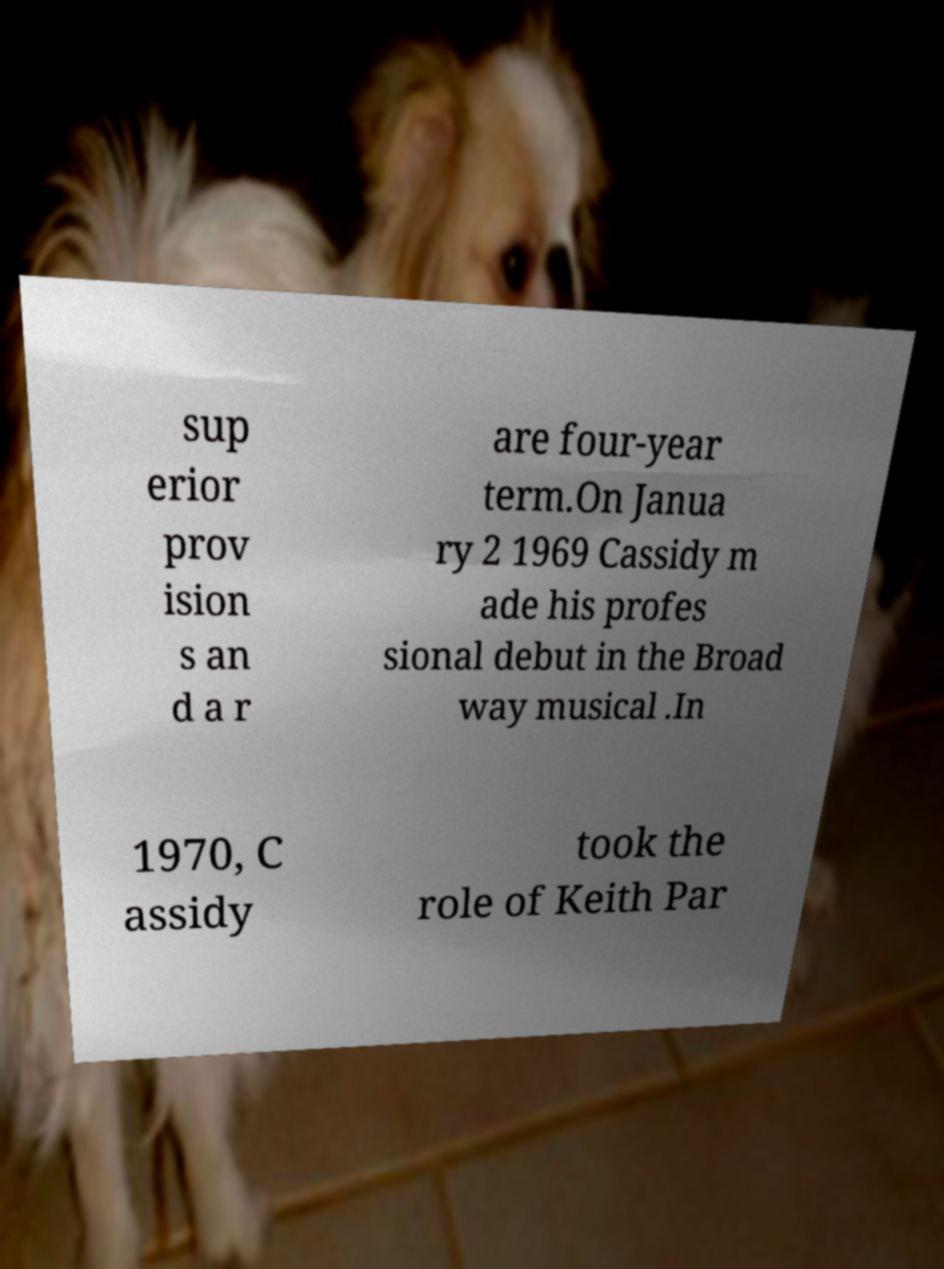Can you accurately transcribe the text from the provided image for me? sup erior prov ision s an d a r are four-year term.On Janua ry 2 1969 Cassidy m ade his profes sional debut in the Broad way musical .In 1970, C assidy took the role of Keith Par 